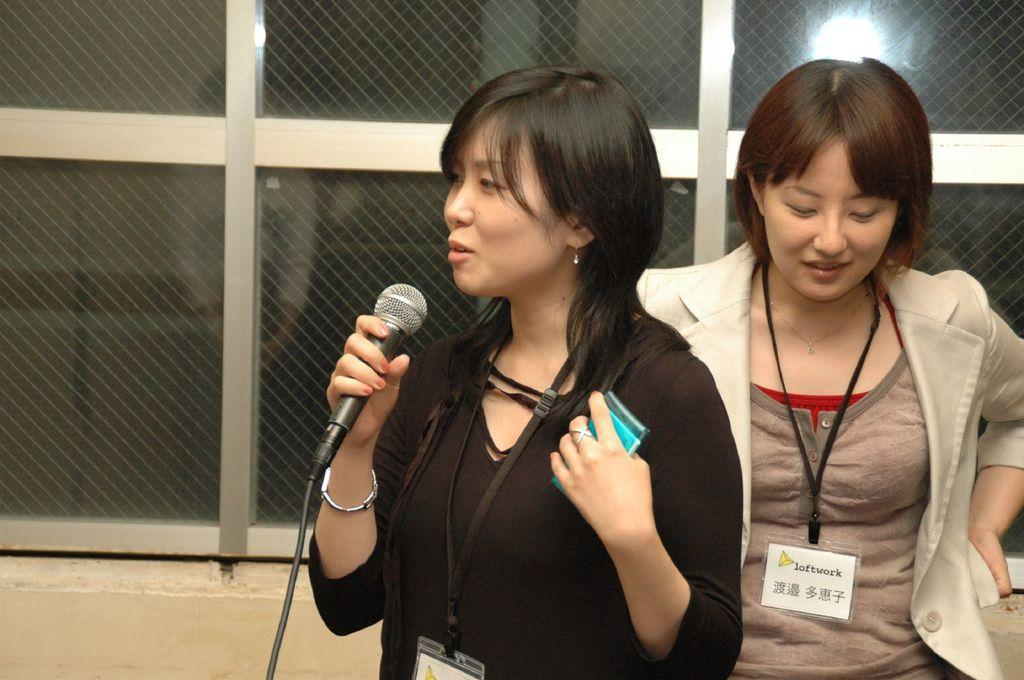How many people are in the image? There are two women in the image. What is one of the women holding? One of the women is holding a mic. What type of flag is being smashed by the women in the image? There is no flag present in the image, nor is there any indication of smashing or destruction. 